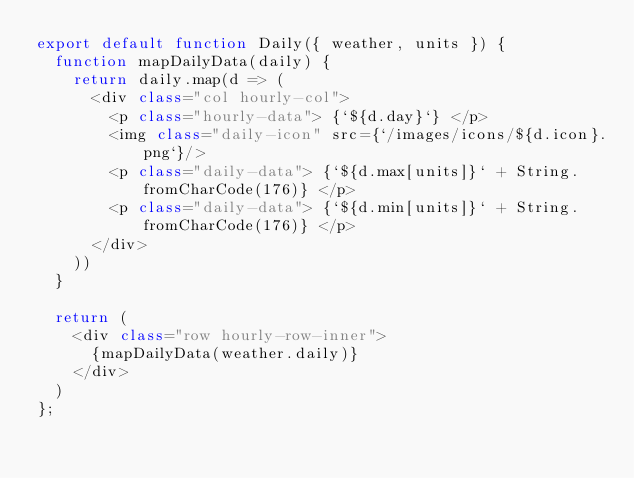<code> <loc_0><loc_0><loc_500><loc_500><_JavaScript_>export default function Daily({ weather, units }) {
  function mapDailyData(daily) {
    return daily.map(d => (
      <div class="col hourly-col">
        <p class="hourly-data"> {`${d.day}`} </p>
        <img class="daily-icon" src={`/images/icons/${d.icon}.png`}/>
        <p class="daily-data"> {`${d.max[units]}` + String.fromCharCode(176)} </p>
        <p class="daily-data"> {`${d.min[units]}` + String.fromCharCode(176)} </p>
      </div>
    ))
  }

  return (
    <div class="row hourly-row-inner">
      {mapDailyData(weather.daily)}
    </div>
  )
};
</code> 